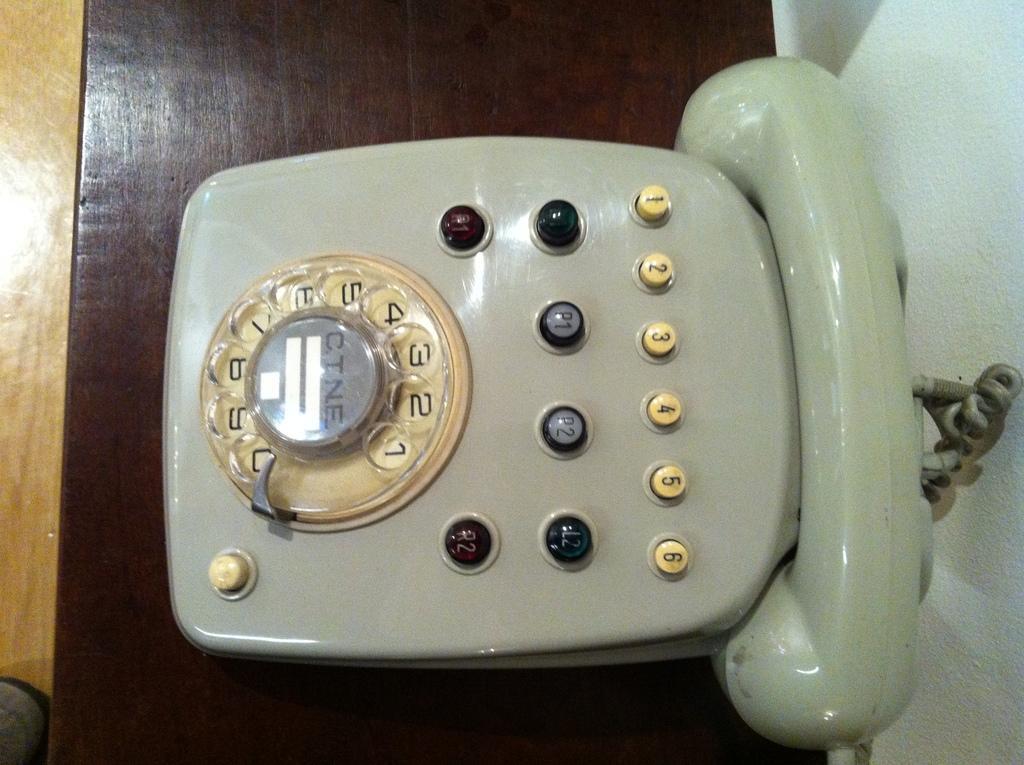Could you give a brief overview of what you see in this image? This image consists of a telephone. It is kept on a wooden table. At the bottom, there is a floor. On the right, there is a wall. 